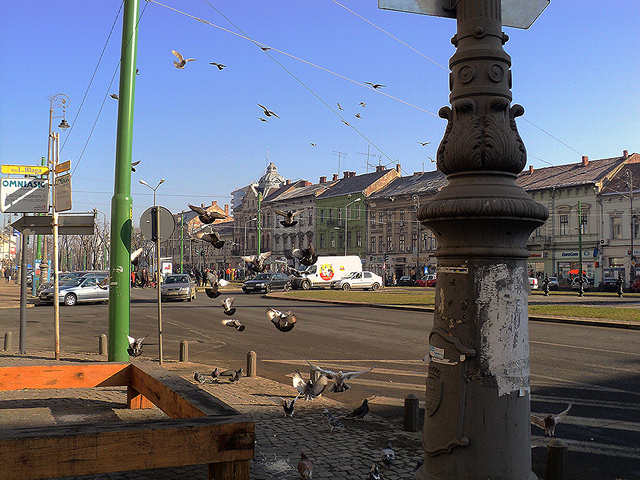Read all the text in this image. OMNIASIC 